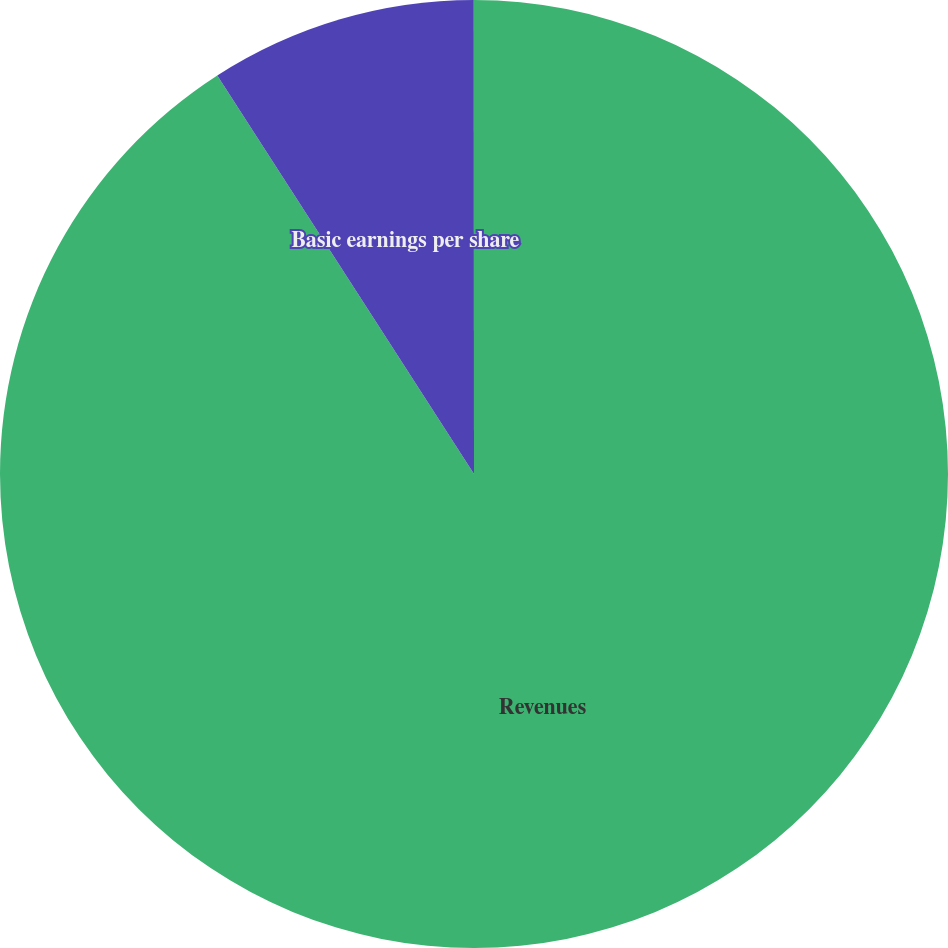Convert chart. <chart><loc_0><loc_0><loc_500><loc_500><pie_chart><fcel>Revenues<fcel>Basic earnings per share<fcel>Diluted earnings per share<nl><fcel>90.9%<fcel>9.1%<fcel>0.01%<nl></chart> 